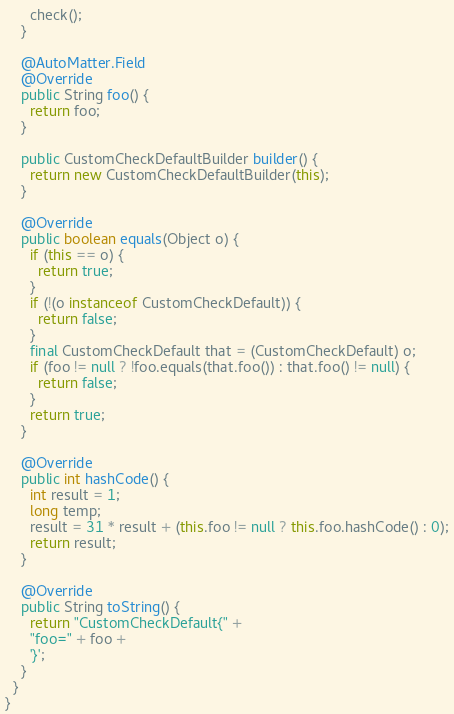Convert code to text. <code><loc_0><loc_0><loc_500><loc_500><_Java_>      check();
    }

    @AutoMatter.Field
    @Override
    public String foo() {
      return foo;
    }

    public CustomCheckDefaultBuilder builder() {
      return new CustomCheckDefaultBuilder(this);
    }

    @Override
    public boolean equals(Object o) {
      if (this == o) {
        return true;
      }
      if (!(o instanceof CustomCheckDefault)) {
        return false;
      }
      final CustomCheckDefault that = (CustomCheckDefault) o;
      if (foo != null ? !foo.equals(that.foo()) : that.foo() != null) {
        return false;
      }
      return true;
    }

    @Override
    public int hashCode() {
      int result = 1;
      long temp;
      result = 31 * result + (this.foo != null ? this.foo.hashCode() : 0);
      return result;
    }

    @Override
    public String toString() {
      return "CustomCheckDefault{" +
      "foo=" + foo +
      '}';
    }
  }
}
</code> 